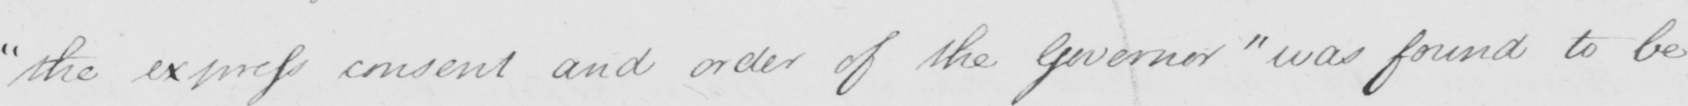Please transcribe the handwritten text in this image. " the express consent and order of the Governor "  was found to be 